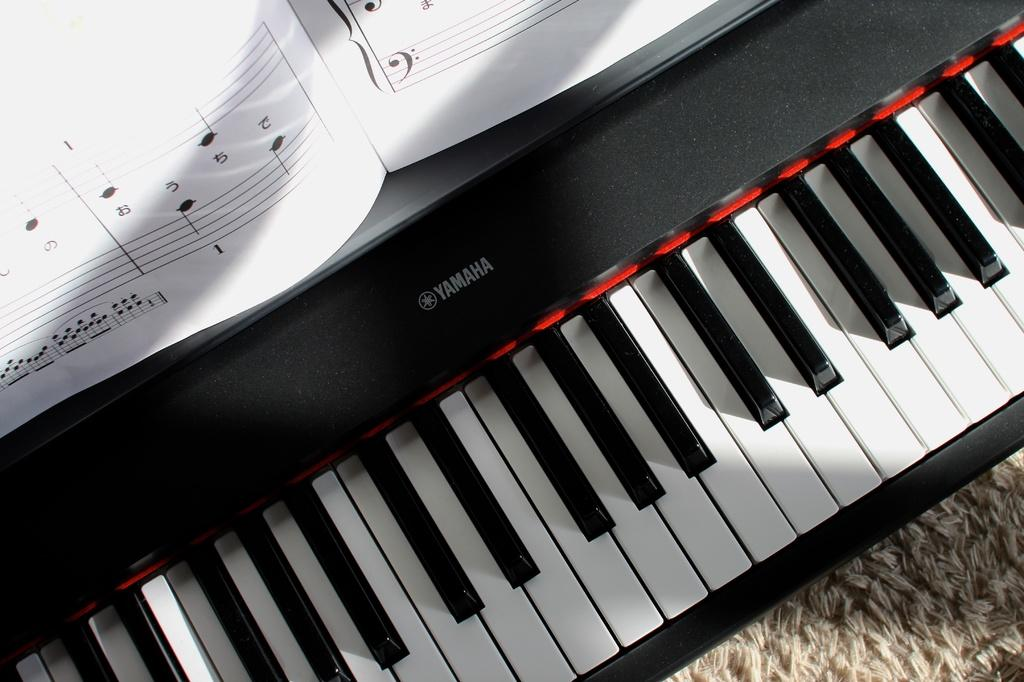What type of musical instrument is in the image? There is a keyboard in the image. What colors are the keys on the keyboard? The keyboard has white keys and black keys. What brand is the keyboard? "Yamaha" is written on the keyboard. What is placed on top of the keyboard? There is a paper on the keyboard. What type of ship can be seen sailing through the grass in the image? There is no ship or grass present in the image; it features a keyboard with a paper on top. What is the weather like in the image? The weather cannot be determined from the image, as it only shows a keyboard with a paper on top. 